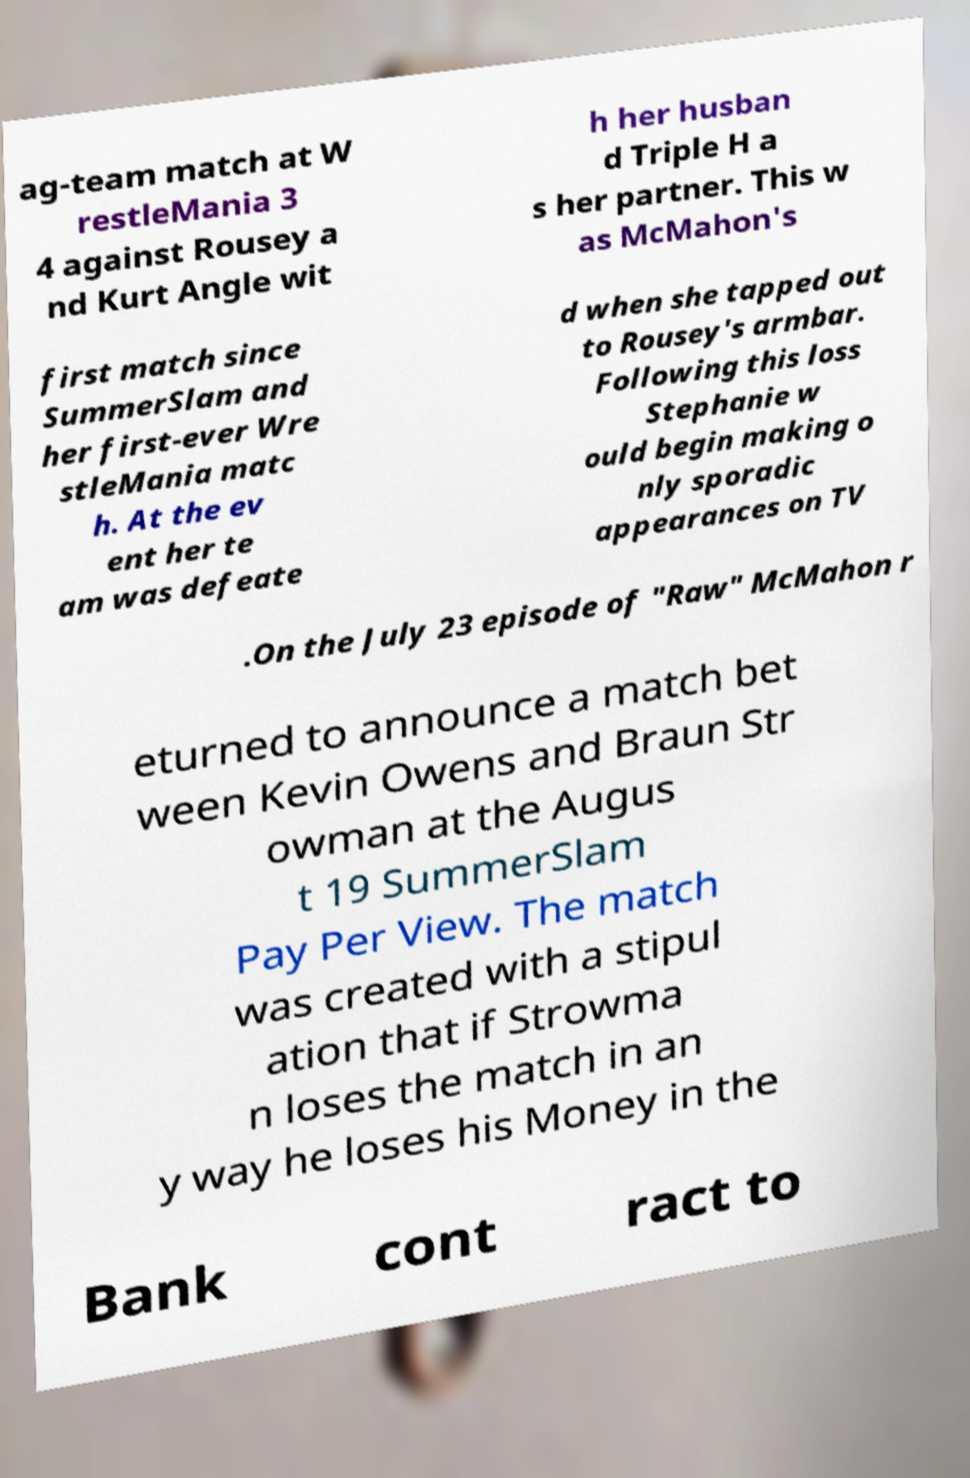What messages or text are displayed in this image? I need them in a readable, typed format. ag-team match at W restleMania 3 4 against Rousey a nd Kurt Angle wit h her husban d Triple H a s her partner. This w as McMahon's first match since SummerSlam and her first-ever Wre stleMania matc h. At the ev ent her te am was defeate d when she tapped out to Rousey's armbar. Following this loss Stephanie w ould begin making o nly sporadic appearances on TV .On the July 23 episode of "Raw" McMahon r eturned to announce a match bet ween Kevin Owens and Braun Str owman at the Augus t 19 SummerSlam Pay Per View. The match was created with a stipul ation that if Strowma n loses the match in an y way he loses his Money in the Bank cont ract to 